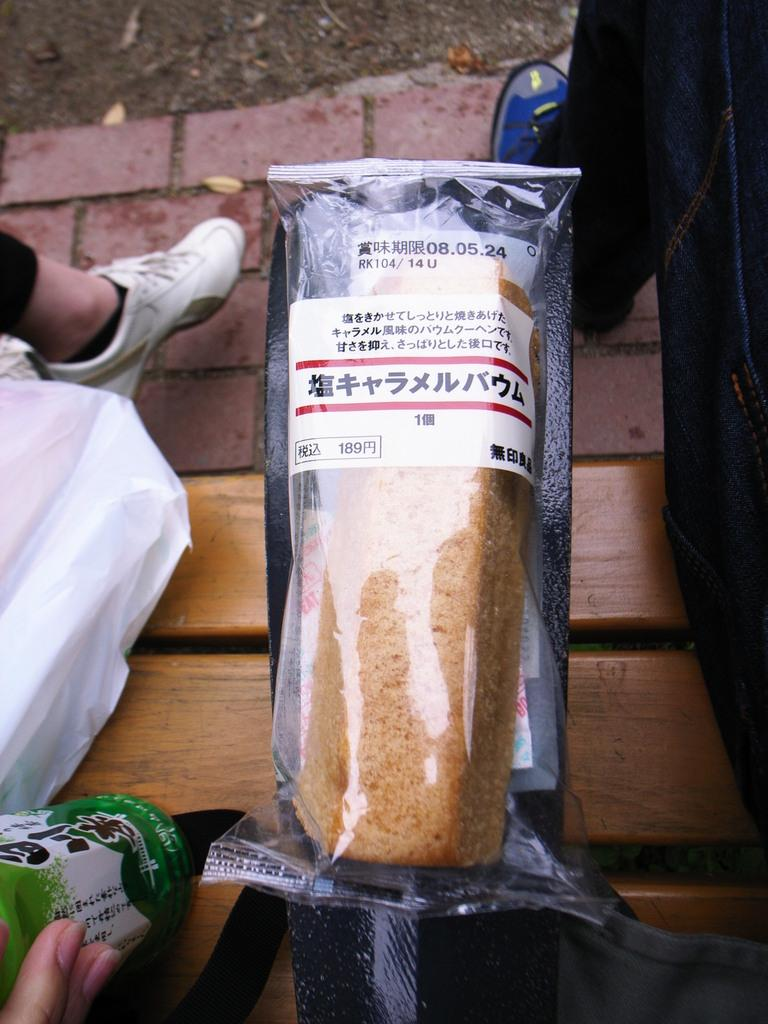What type of seating is visible in the image? There is a bench in the image. Who is sitting on the bench? Two men are sitting on the bench. What object is placed on the bench between the two men? There is a bread in the middle of the bench. What type of gold jewelry is the man on the left wearing in the image? There is no gold jewelry visible on the man on the left in the image. 